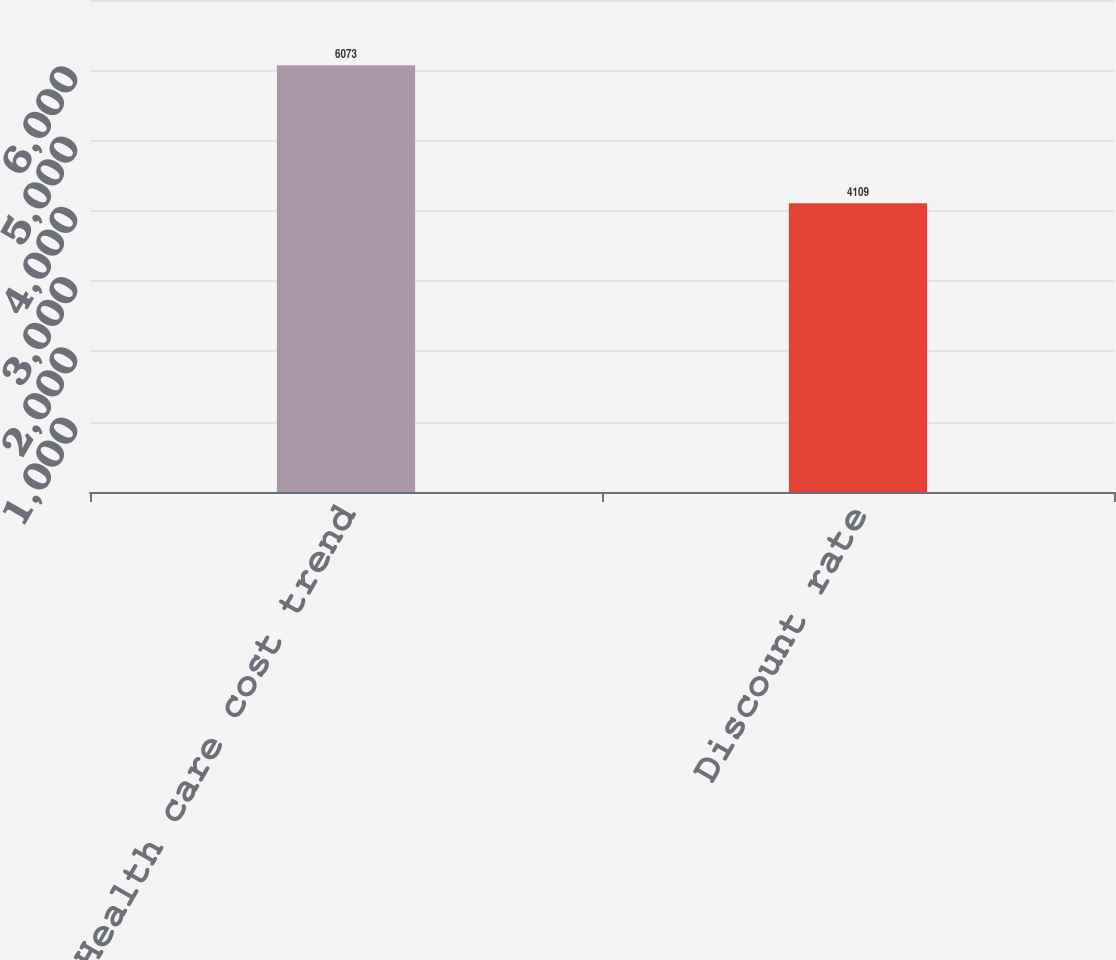Convert chart. <chart><loc_0><loc_0><loc_500><loc_500><bar_chart><fcel>Health care cost trend<fcel>Discount rate<nl><fcel>6073<fcel>4109<nl></chart> 